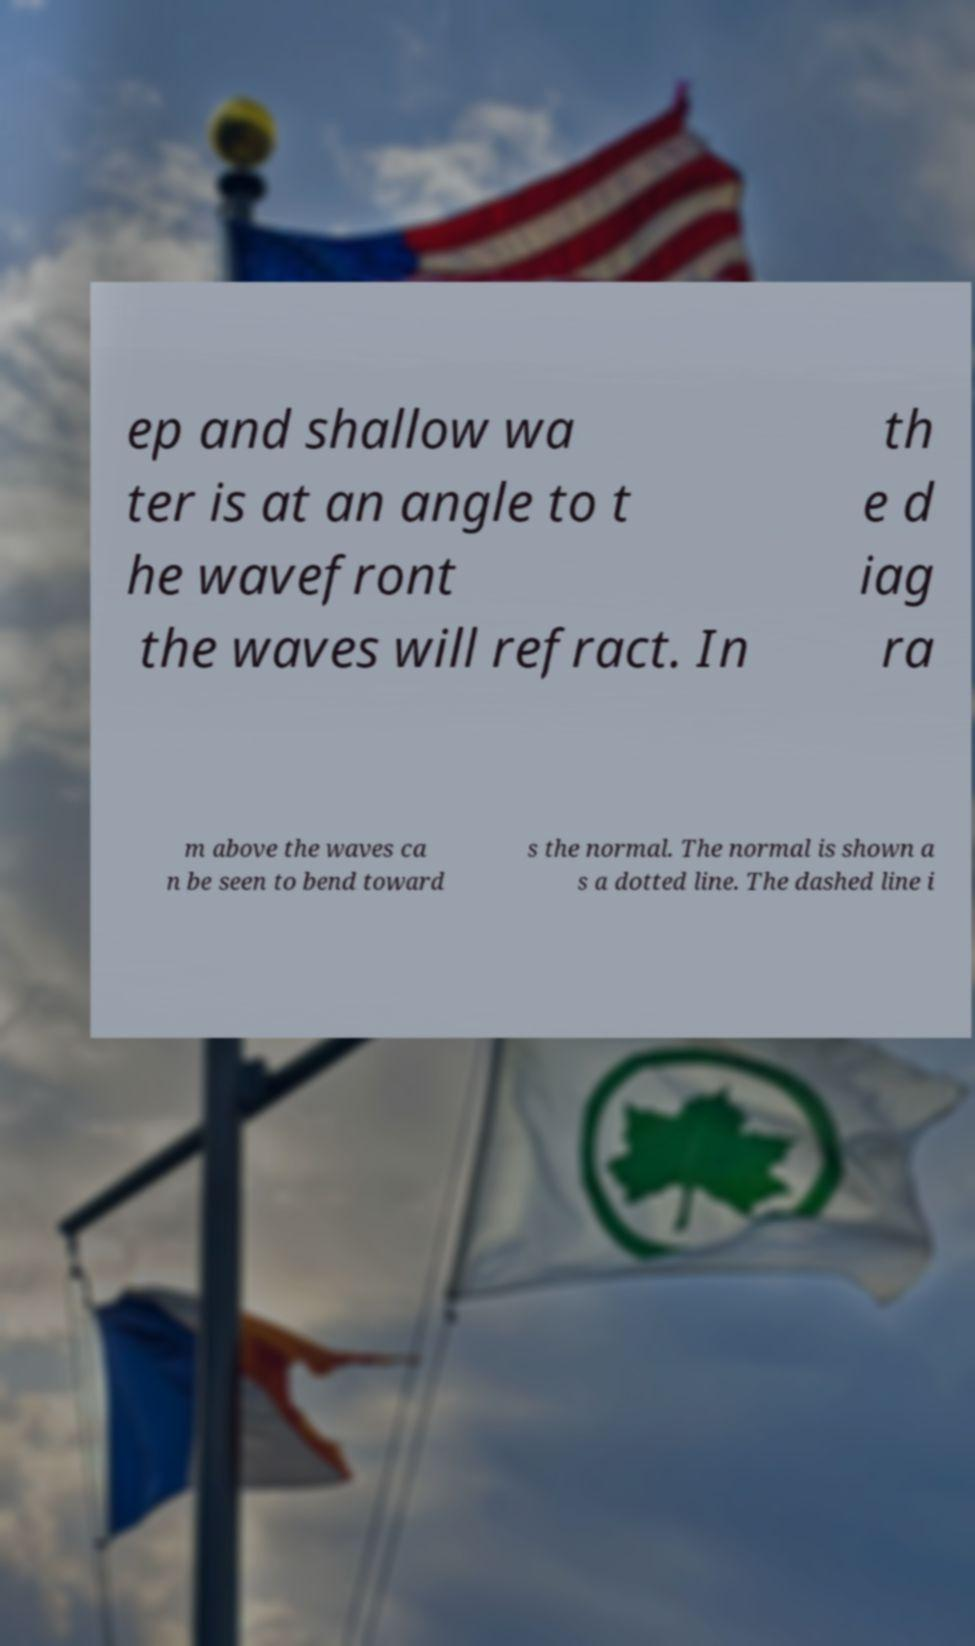Please identify and transcribe the text found in this image. ep and shallow wa ter is at an angle to t he wavefront the waves will refract. In th e d iag ra m above the waves ca n be seen to bend toward s the normal. The normal is shown a s a dotted line. The dashed line i 